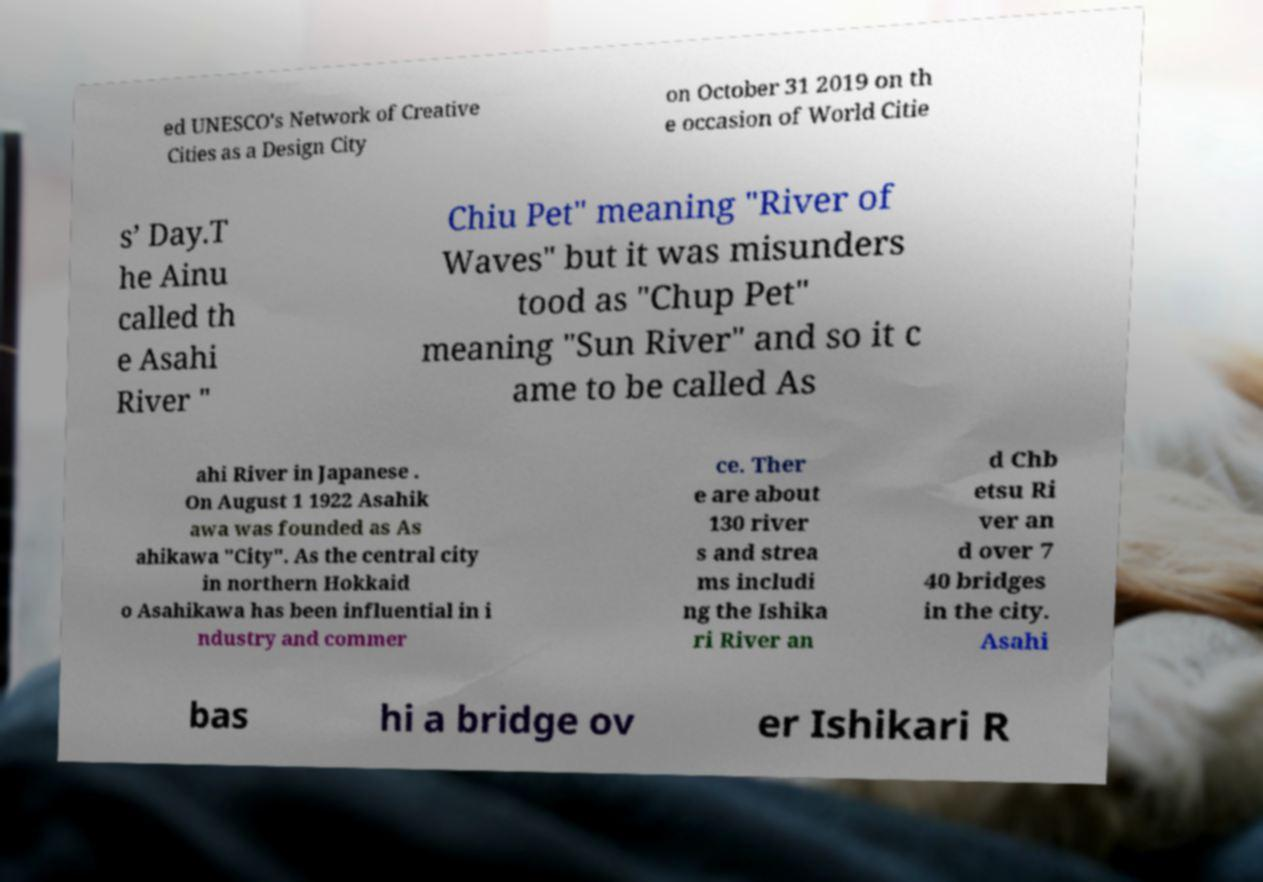There's text embedded in this image that I need extracted. Can you transcribe it verbatim? ed UNESCO's Network of Creative Cities as a Design City on October 31 2019 on th e occasion of World Citie s’ Day.T he Ainu called th e Asahi River " Chiu Pet" meaning "River of Waves" but it was misunders tood as "Chup Pet" meaning "Sun River" and so it c ame to be called As ahi River in Japanese . On August 1 1922 Asahik awa was founded as As ahikawa "City". As the central city in northern Hokkaid o Asahikawa has been influential in i ndustry and commer ce. Ther e are about 130 river s and strea ms includi ng the Ishika ri River an d Chb etsu Ri ver an d over 7 40 bridges in the city. Asahi bas hi a bridge ov er Ishikari R 